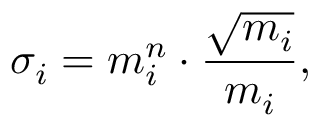<formula> <loc_0><loc_0><loc_500><loc_500>\sigma _ { i } = m _ { i } ^ { n } \cdot \frac { \sqrt { m _ { i } } } { m _ { i } } ,</formula> 